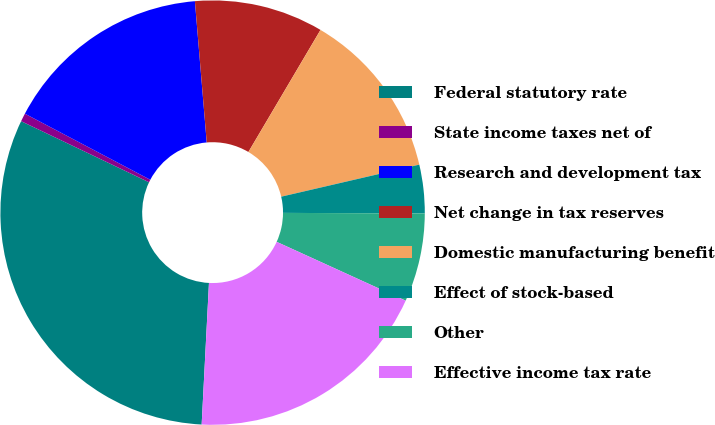Convert chart to OTSL. <chart><loc_0><loc_0><loc_500><loc_500><pie_chart><fcel>Federal statutory rate<fcel>State income taxes net of<fcel>Research and development tax<fcel>Net change in tax reserves<fcel>Domestic manufacturing benefit<fcel>Effect of stock-based<fcel>Other<fcel>Effective income tax rate<nl><fcel>31.27%<fcel>0.63%<fcel>15.95%<fcel>9.82%<fcel>12.88%<fcel>3.69%<fcel>6.75%<fcel>19.01%<nl></chart> 